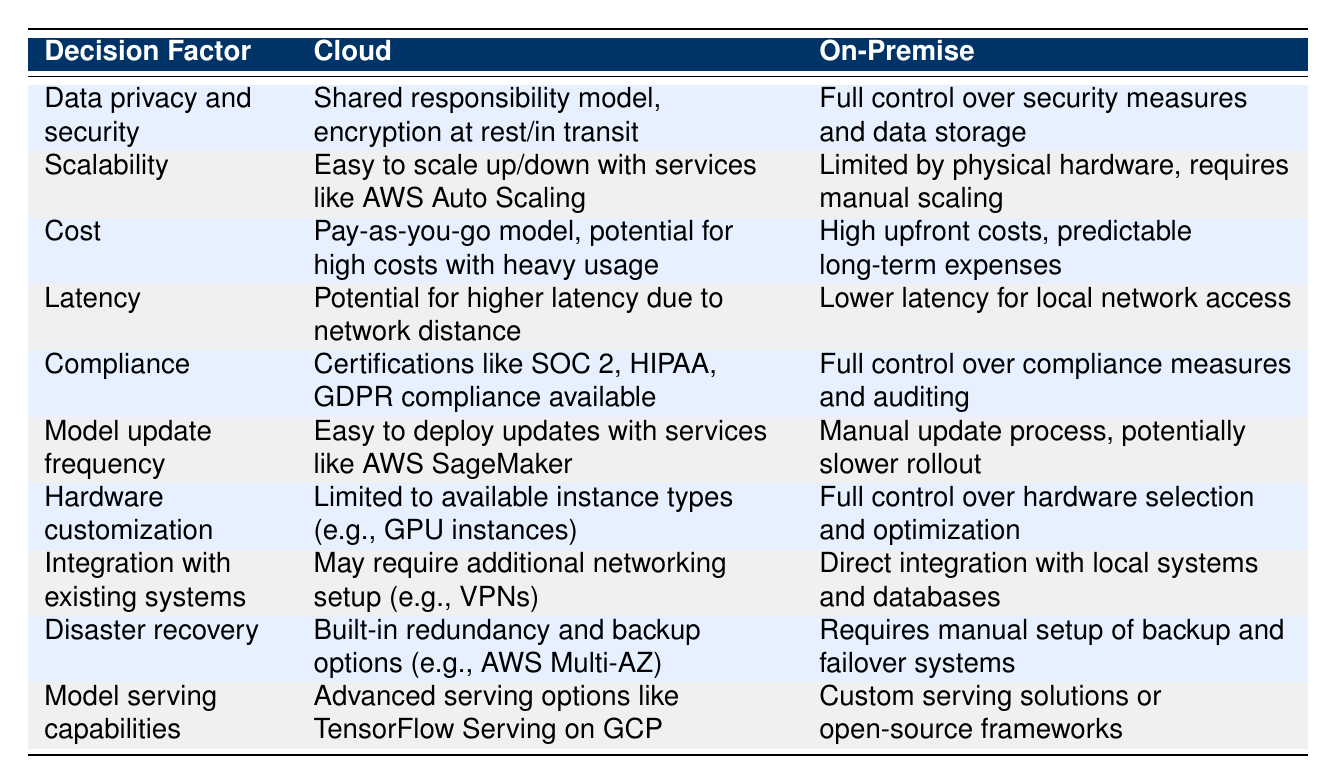What is the model update frequency advantage for cloud deployment? According to the table, the model update frequency for cloud deployment can be easily managed using services like AWS SageMaker, indicating a quicker deployment process for updates compared to the manual update process in on-premise deployment.
Answer: Easy to deploy updates What does the cloud offer for disaster recovery capabilities? The table states that cloud deployment provides built-in redundancy and backup options such as AWS Multi-AZ, which simplifies disaster recovery compared to the manual setup required for on-premise systems.
Answer: Built-in redundancy and backup options Is the requirement for hardware customization greater in on-premise than in cloud? The table shows that on-premise deployment allows full control over hardware selection and optimization, indicating a greater need for hardware customization compared to cloud solutions which are limited to available instance types.
Answer: Yes Which deployment option generally has lower latency? The latency for cloud deployment could be higher due to network distance as stated in the table, while on-premise offers lower latency due to local network access. Therefore, on-premise generally has lower latency.
Answer: On-premise What are two compliance aspects of cloud and on-premise deployments? The table highlights that cloud deployments have certifications available like SOC 2, HIPAA, and GDPR compliance, while on-premise deployment offers full control over compliance measures and auditing. These differences illustrate regulatory and auditing control aspects for both environments.
Answer: Certifications and full control What are the potential costs associated with cloud deployment? The table describes the cost structure for cloud deployment as a pay-as-you-go model, which could potentially lead to high costs with heavy usage, whereas on-premise deployment has high upfront costs and predictable long-term expenses.
Answer: Pay-as-you-go model, potential for high costs Is the integration with existing systems easier in on-premise deployments? According to the table, on-premise deployments allow direct integration with local systems and databases, while cloud deployments may require additional networking setup such as VPNs, indicating that on-premise integration is generally easier.
Answer: Yes 